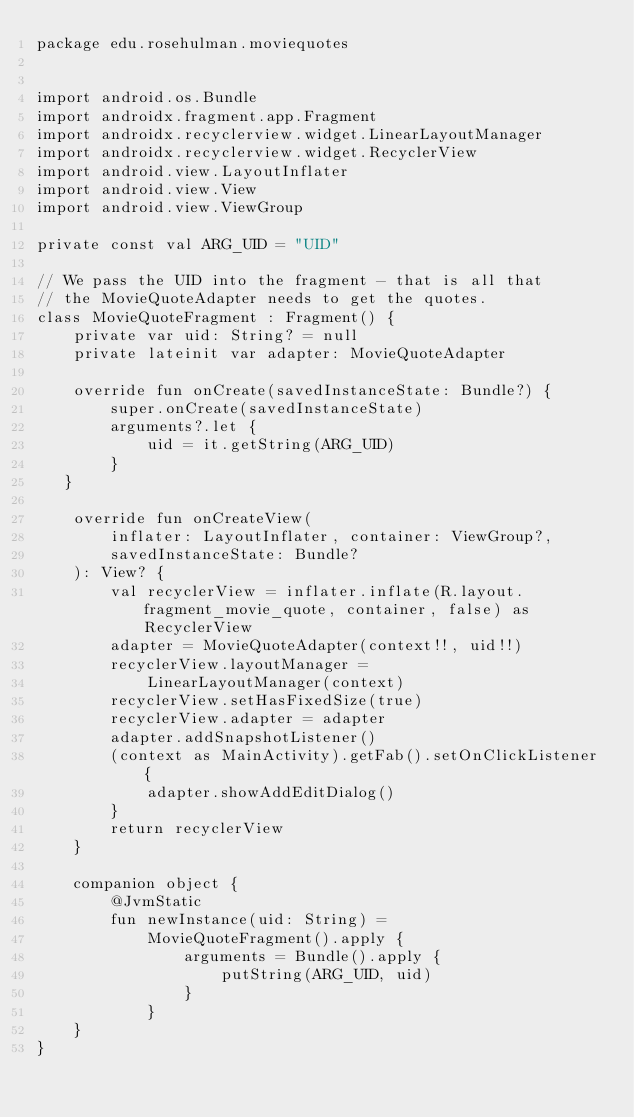<code> <loc_0><loc_0><loc_500><loc_500><_Kotlin_>package edu.rosehulman.moviequotes


import android.os.Bundle
import androidx.fragment.app.Fragment
import androidx.recyclerview.widget.LinearLayoutManager
import androidx.recyclerview.widget.RecyclerView
import android.view.LayoutInflater
import android.view.View
import android.view.ViewGroup

private const val ARG_UID = "UID"

// We pass the UID into the fragment - that is all that
// the MovieQuoteAdapter needs to get the quotes.
class MovieQuoteFragment : Fragment() {
    private var uid: String? = null
    private lateinit var adapter: MovieQuoteAdapter

    override fun onCreate(savedInstanceState: Bundle?) {
        super.onCreate(savedInstanceState)
        arguments?.let {
            uid = it.getString(ARG_UID)
        }
   }

    override fun onCreateView(
        inflater: LayoutInflater, container: ViewGroup?,
        savedInstanceState: Bundle?
    ): View? {
        val recyclerView = inflater.inflate(R.layout.fragment_movie_quote, container, false) as RecyclerView
        adapter = MovieQuoteAdapter(context!!, uid!!)
        recyclerView.layoutManager =
            LinearLayoutManager(context)
        recyclerView.setHasFixedSize(true)
        recyclerView.adapter = adapter
        adapter.addSnapshotListener()
        (context as MainActivity).getFab().setOnClickListener {
            adapter.showAddEditDialog()
        }
        return recyclerView
    }

    companion object {
        @JvmStatic
        fun newInstance(uid: String) =
            MovieQuoteFragment().apply {
                arguments = Bundle().apply {
                    putString(ARG_UID, uid)
                }
            }
    }
}
</code> 